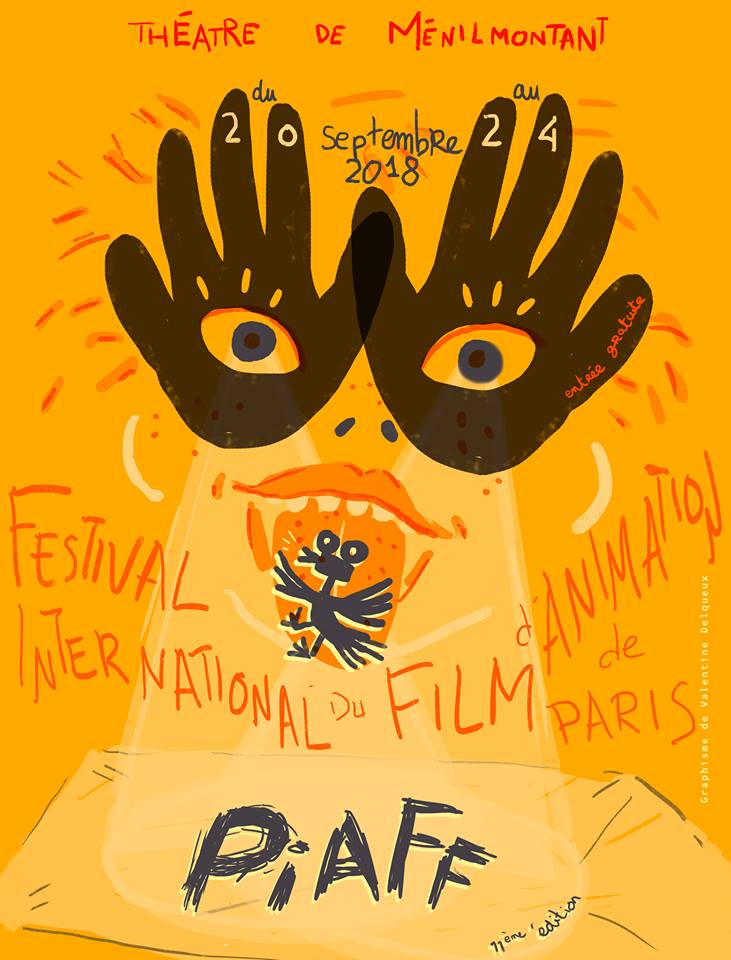Can you create a short story inspired by the characters in this poster? Once upon a time in a vibrant land of creativity, a quirky character named Paffy, who loved to dance, lived inside the poster of the Paris International Animation Film Festival. Paffy had magical powers to bring colors and drawings to life. Every year, as the festival approached, Paffy would shake the letters 'P·A·F' to release a cascade of creativity that flowed into the streets of Paris, inviting people of all ages to come and celebrate. This magical journey would start with dancing hands with eyes, guiding curious minds to the wonders of animation and storytelling. As the festival dates approached, the streets would light up with the animation wonders, creating a fiesta of color, joy, and endless imagination.  Can you set a scene for the opening night of the Paris International Animation Film Festival as depicted in the poster? As the sun sets over the charming Théâtre de Ménilmontant on the opening night of the Paris International Animation Film Festival, a golden glow blankets the venue, echoing the warm hues of the poster. The streets buzz with excitement as artists, filmmakers, and animation enthusiasts gather, drawn in by the large, inviting poster. The whimsical hands painted with eyes seem to wave at the crowd, creating an atmosphere of lively anticipation. Inside, the theater’s décor resonates with the poster’s vibrant colors and playful illustrations. The festival begins with a spectacular display, turning the theater into a magical landscape where animations leap off the screen, captivating the audience. Characters like the playful Paffy make surprise appearances, dancing through projections and interacting with delighted guests, creating an unforgettable start to the festival. 